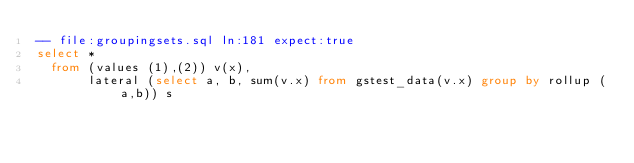Convert code to text. <code><loc_0><loc_0><loc_500><loc_500><_SQL_>-- file:groupingsets.sql ln:181 expect:true
select *
  from (values (1),(2)) v(x),
       lateral (select a, b, sum(v.x) from gstest_data(v.x) group by rollup (a,b)) s
</code> 